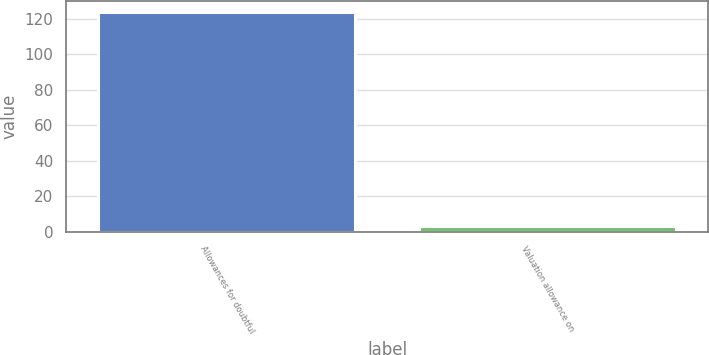<chart> <loc_0><loc_0><loc_500><loc_500><bar_chart><fcel>Allowances for doubtful<fcel>Valuation allowance on<nl><fcel>124<fcel>3<nl></chart> 